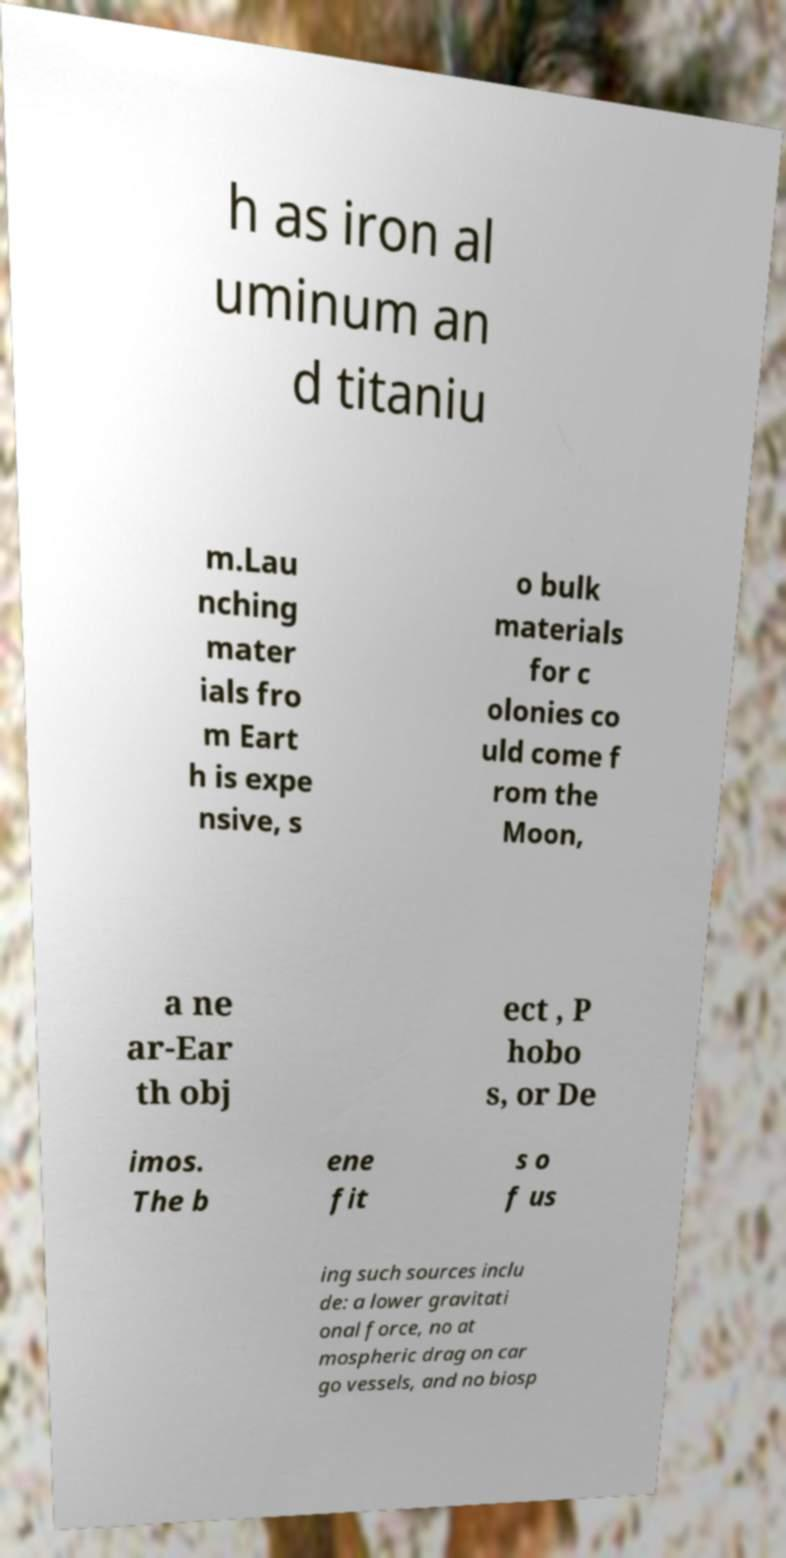Please read and relay the text visible in this image. What does it say? h as iron al uminum an d titaniu m.Lau nching mater ials fro m Eart h is expe nsive, s o bulk materials for c olonies co uld come f rom the Moon, a ne ar-Ear th obj ect , P hobo s, or De imos. The b ene fit s o f us ing such sources inclu de: a lower gravitati onal force, no at mospheric drag on car go vessels, and no biosp 